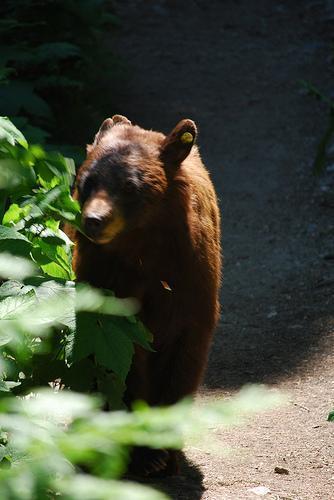How many bear are in the photo?
Give a very brief answer. 1. 